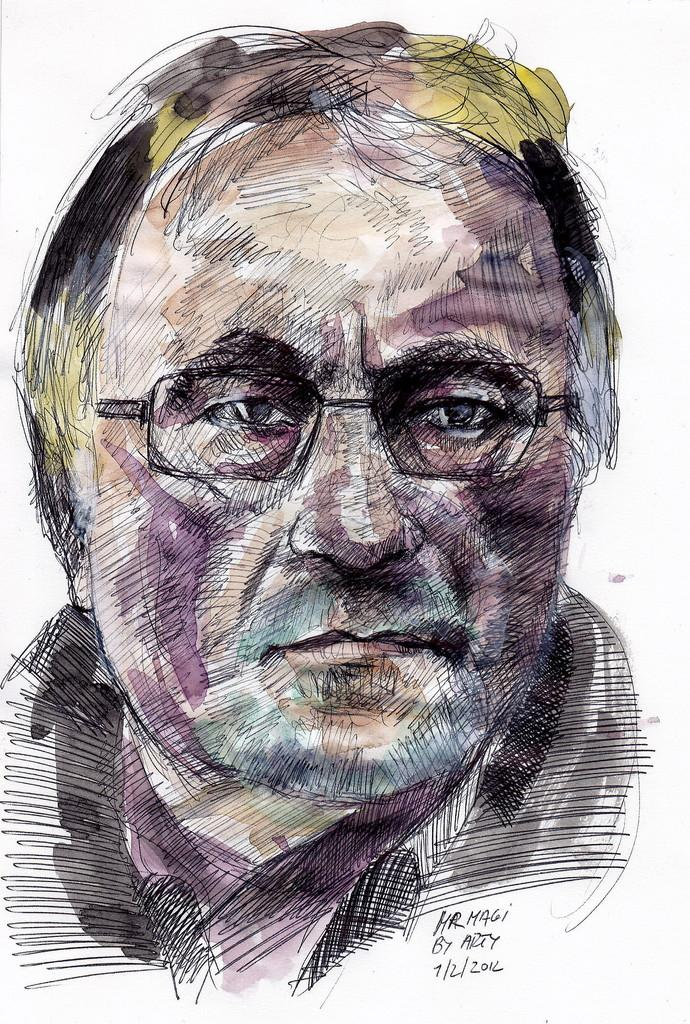What is depicted in the image? There is a sketch of a person in the image. Can you describe the person in the sketch? The person in the sketch is wearing glasses. Is there any text present in the image? Yes, there is text written in the bottom right corner of the image. How does the person in the sketch contribute to the growth of the bridge in the image? There is no bridge present in the image, and the person in the sketch is not contributing to any growth. 